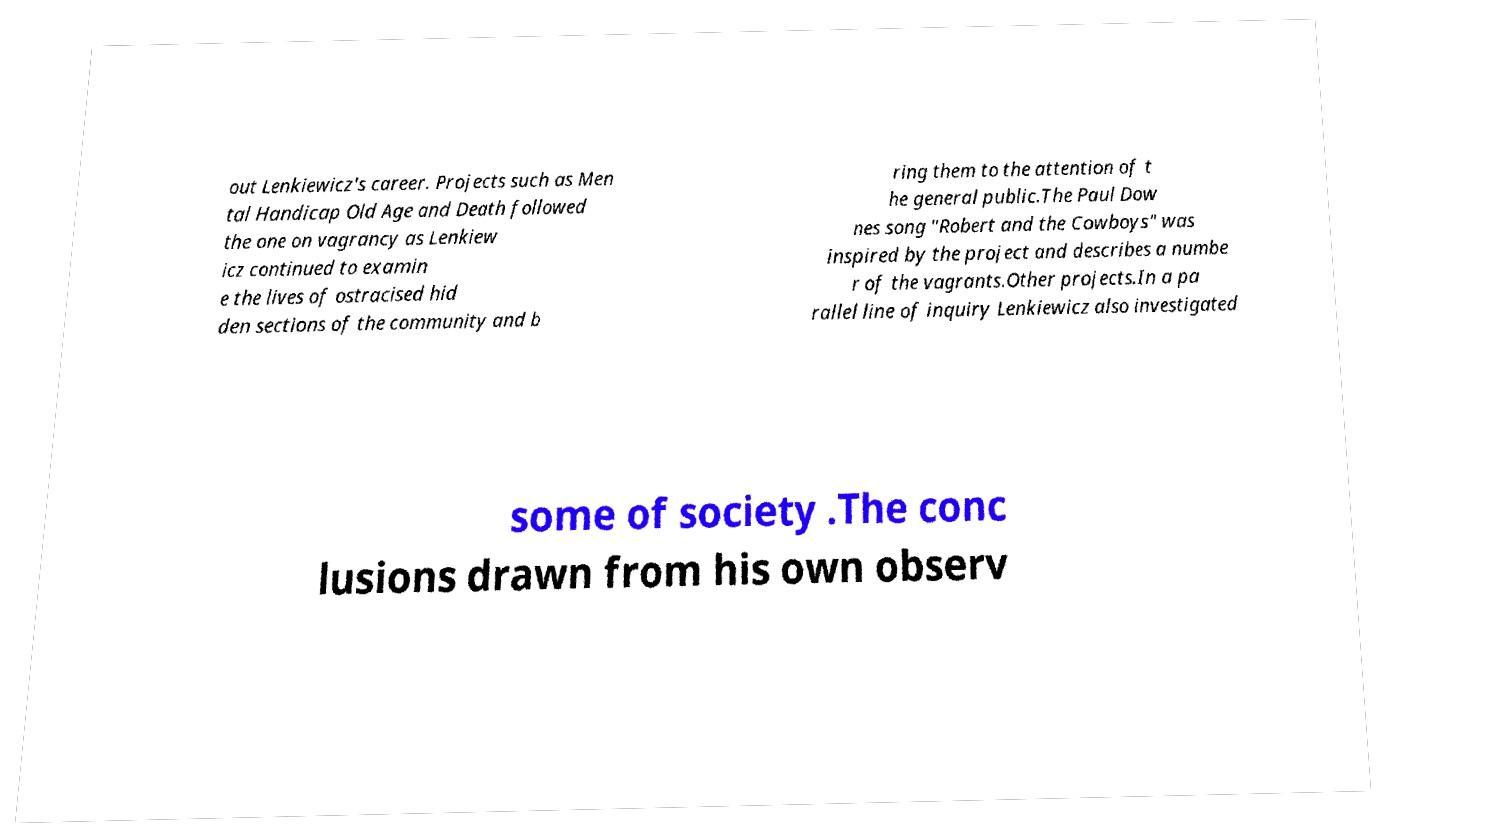There's text embedded in this image that I need extracted. Can you transcribe it verbatim? out Lenkiewicz's career. Projects such as Men tal Handicap Old Age and Death followed the one on vagrancy as Lenkiew icz continued to examin e the lives of ostracised hid den sections of the community and b ring them to the attention of t he general public.The Paul Dow nes song "Robert and the Cowboys" was inspired by the project and describes a numbe r of the vagrants.Other projects.In a pa rallel line of inquiry Lenkiewicz also investigated some of society .The conc lusions drawn from his own observ 